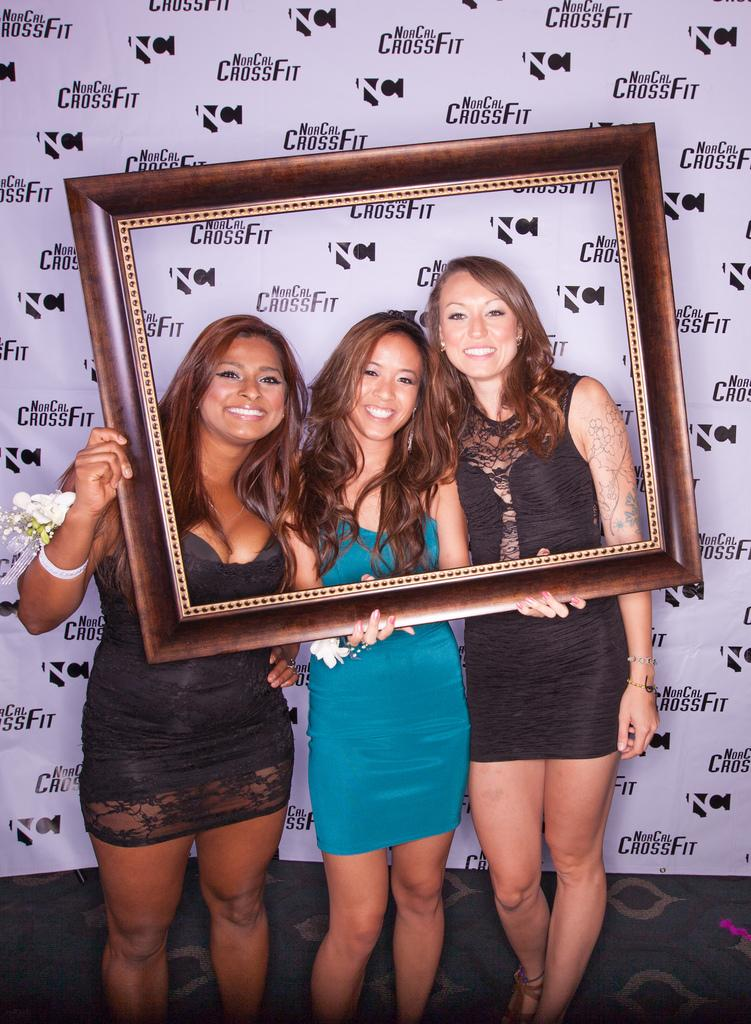How many women are present in the image? There are three women in the image. What is the facial expression of the women? The women are smiling. What object are the women holding? The women are holding an empty photo frame. What can be seen in the background behind the women? There is a banner visible behind the women. What type of corn can be seen growing in the photo frame? There is no corn present in the image, as the photo frame is empty. 